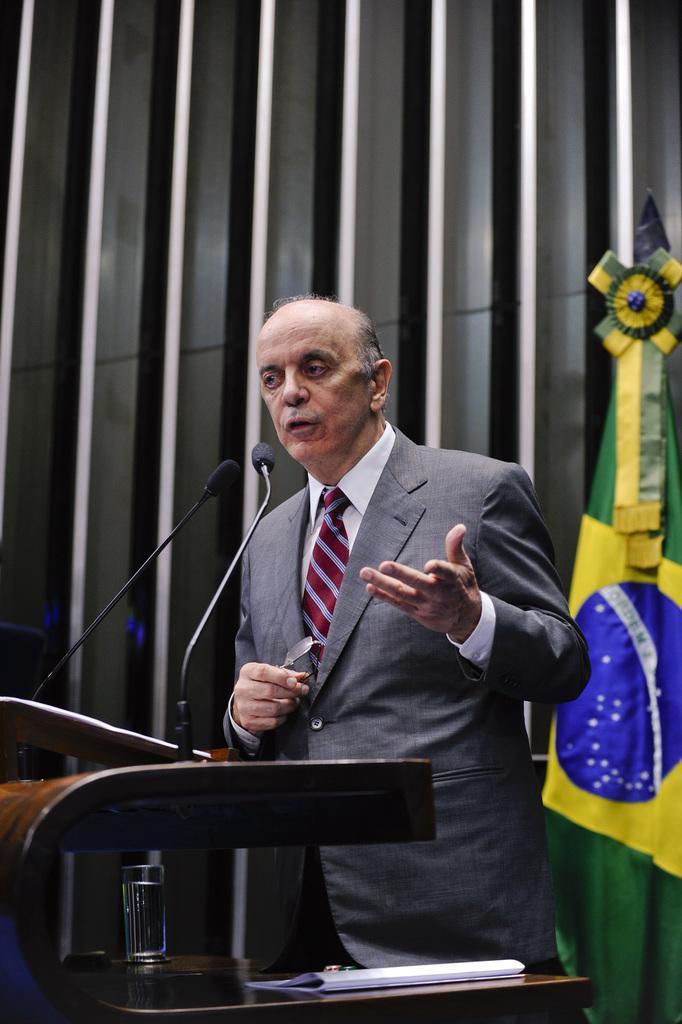In one or two sentences, can you explain what this image depicts? In this picture we can see a man is standing in front of a podium, he is holding spectacles and speaking something, there are two microphones in front of him, we can see a table in the front, there is a glass of water and a paper present on the table, on the right side there is a cloth. 